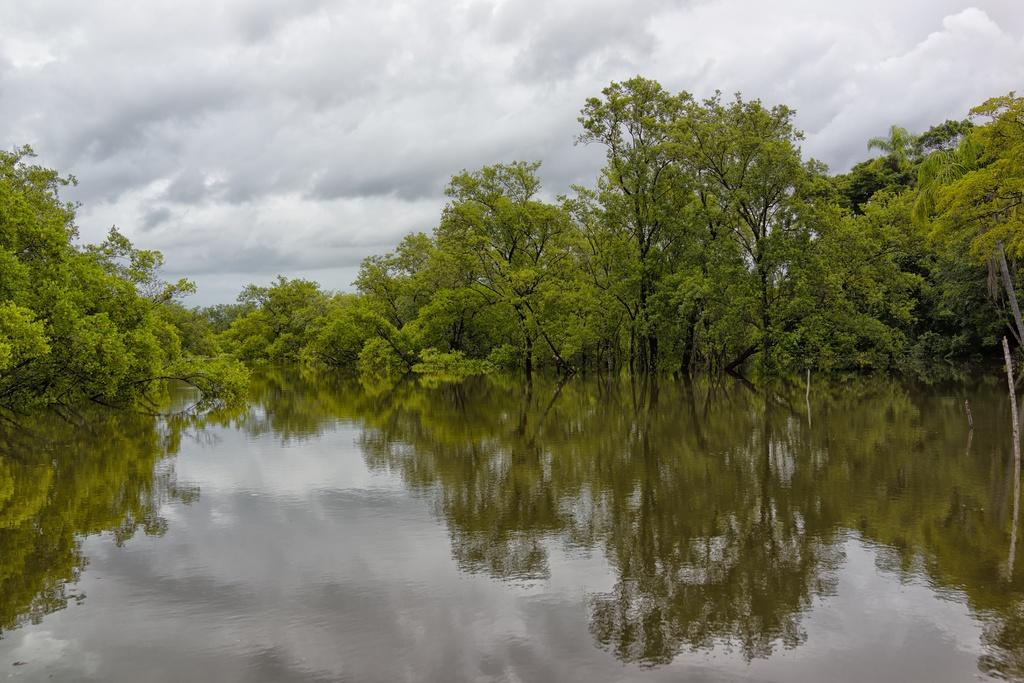What is the primary element visible in the image? There is water in the image. What type of vegetation is present around the water? There are trees around the water. What can be seen in the background of the image? The sky is visible in the background of the image. How many cactus plants can be seen near the water in the image? There are no cactus plants visible in the image; only trees are present around the water. 